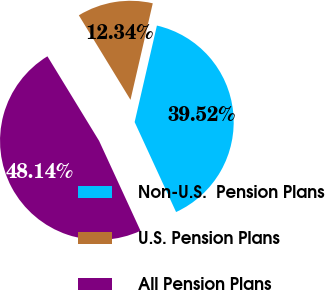<chart> <loc_0><loc_0><loc_500><loc_500><pie_chart><fcel>Non-U.S.  Pension Plans<fcel>U.S. Pension Plans<fcel>All Pension Plans<nl><fcel>39.52%<fcel>12.34%<fcel>48.14%<nl></chart> 